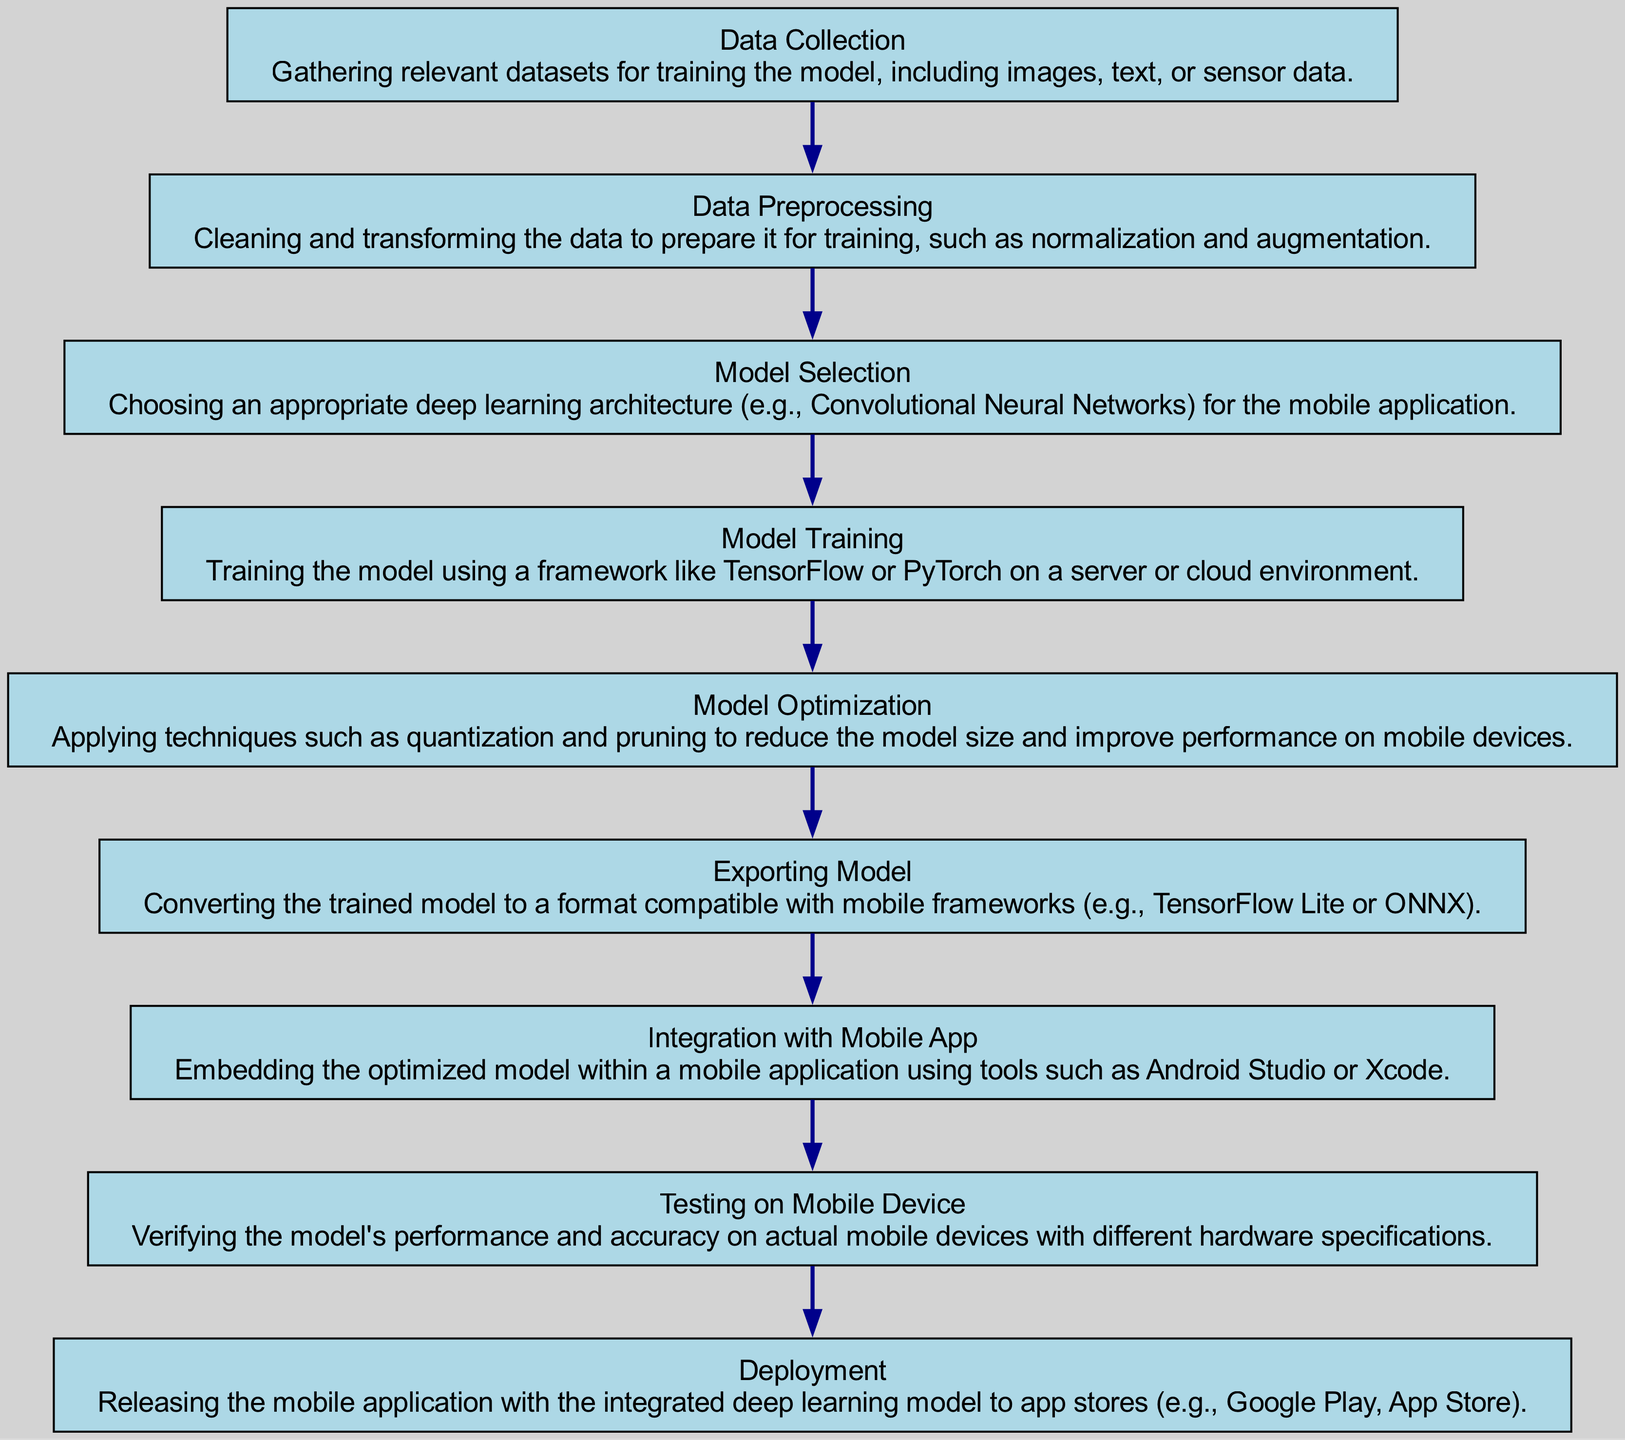What is the first step in the deployment process? The first step identified in the diagram is "Data Collection," which describes gathering relevant datasets for training the model. Therefore, by looking at the topmost node of the chart, we can confirm this is the starting point.
Answer: Data Collection How many nodes are in the flow chart? By counting all the labeled steps represented in the diagram, including the initial node "Data Collection" to the final "Deployment" node, there are a total of nine nodes.
Answer: Nine What is the last step in the deployment process? The last node connected in the flow chart is "Deployment," which indicates the final phase of releasing the mobile application to app stores. This is clear from its position as the last element in the sequence of processes.
Answer: Deployment What comes after Model Optimization? The flow of the diagram shows that after "Model Optimization," the subsequent step is "Exporting Model," signifying that the process follows a sequential order from one step to another.
Answer: Exporting Model Which step involves cleaning and transforming data? The second node in the diagram is "Data Preprocessing," which explicitly details the actions of cleaning and transforming the data before it can be used for training. Therefore, this step is clearly defined in the chart.
Answer: Data Preprocessing What two nodes are directly connected? Analyzing the connections in the diagram, "Model Selection" and "Model Training" are two nodes that are directly linked, as "Model Selection" leads to "Model Training" in the sequential order of tasks.
Answer: Model Selection, Model Training How many edges connect the nodes in this flow chart? Each node in the diagram connects to the next through an edge, and since there are a total of nine nodes, there will be eight directed edges connecting them sequentially, as the first node does not have a predecessor.
Answer: Eight What is the purpose of Model Optimization? The description under the "Model Optimization" node explains that this step aims to apply techniques such as quantization and pruning to enhance the model’s performance while reducing its size for mobile device compatibility. This represents an important aspect of the deployment process.
Answer: To reduce model size and improve performance What comes before Integration with Mobile App? In the sequence of the flow chart, "Exporting Model" is positioned directly before "Integration with Mobile App," showing the logical order of steps in deploying a deep learning model to a mobile platform.
Answer: Exporting Model 